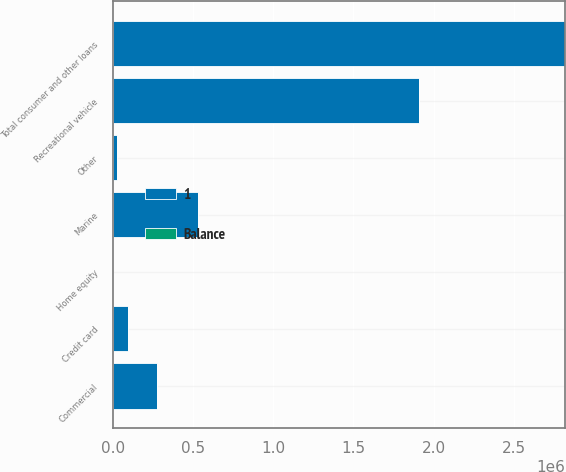Convert chart. <chart><loc_0><loc_0><loc_500><loc_500><stacked_bar_chart><ecel><fcel>Home equity<fcel>Recreational vehicle<fcel>Marine<fcel>Commercial<fcel>Credit card<fcel>Other<fcel>Total consumer and other loans<nl><fcel>1<fcel>39.2<fcel>1.91045e+06<fcel>526580<fcel>272156<fcel>90764<fcel>23334<fcel>2.82329e+06<nl><fcel>Balance<fcel>39.2<fcel>6.3<fcel>1.7<fcel>0.9<fcel>0.3<fcel>0.1<fcel>9.3<nl></chart> 